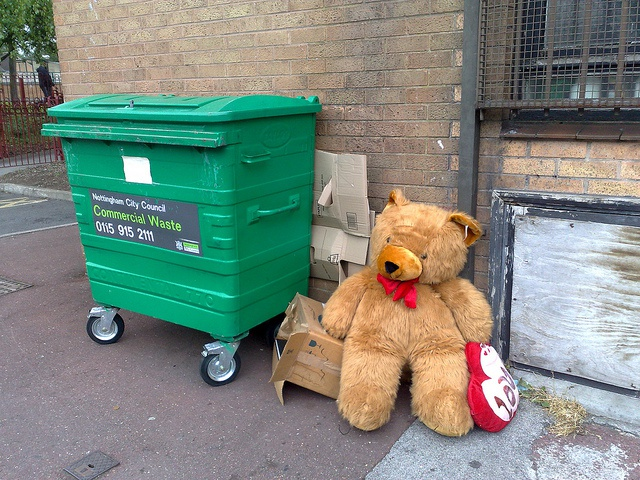Describe the objects in this image and their specific colors. I can see teddy bear in darkgreen and tan tones and people in darkgreen, black, gray, navy, and blue tones in this image. 